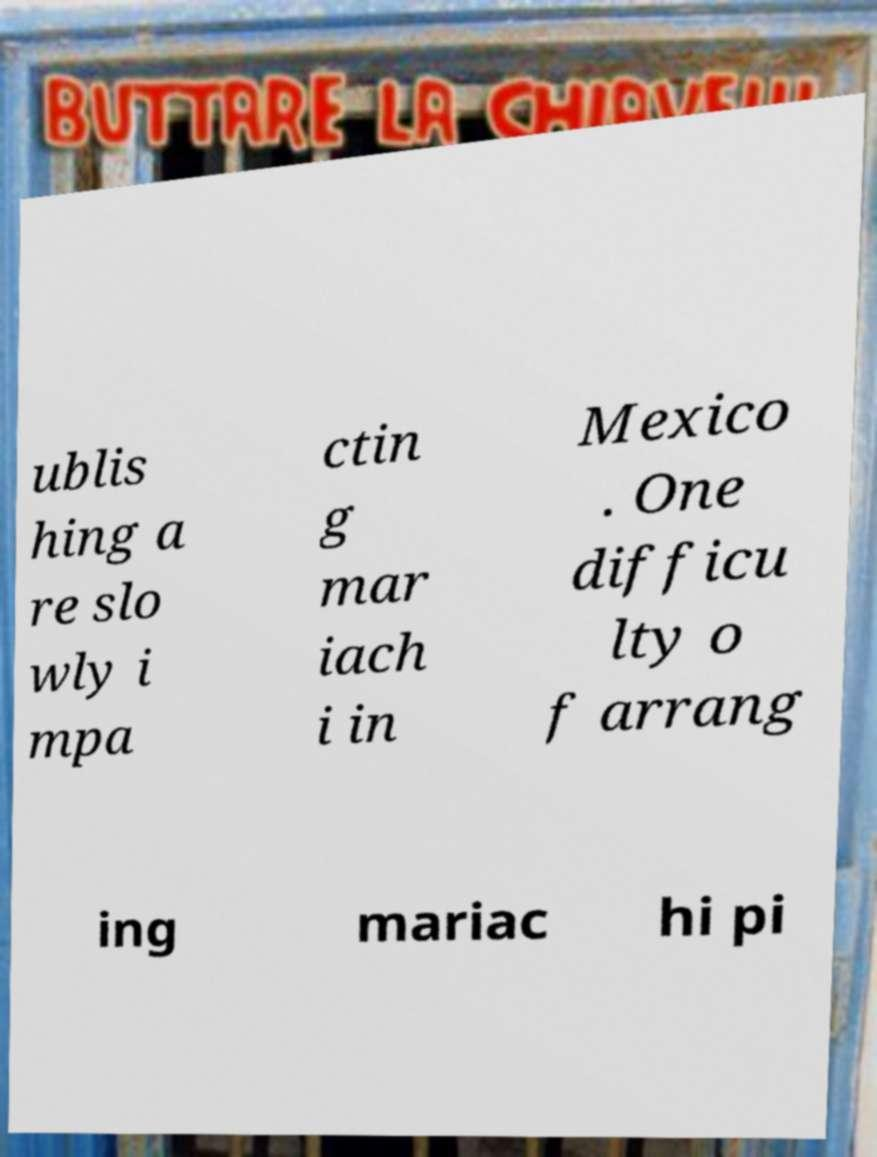I need the written content from this picture converted into text. Can you do that? ublis hing a re slo wly i mpa ctin g mar iach i in Mexico . One difficu lty o f arrang ing mariac hi pi 